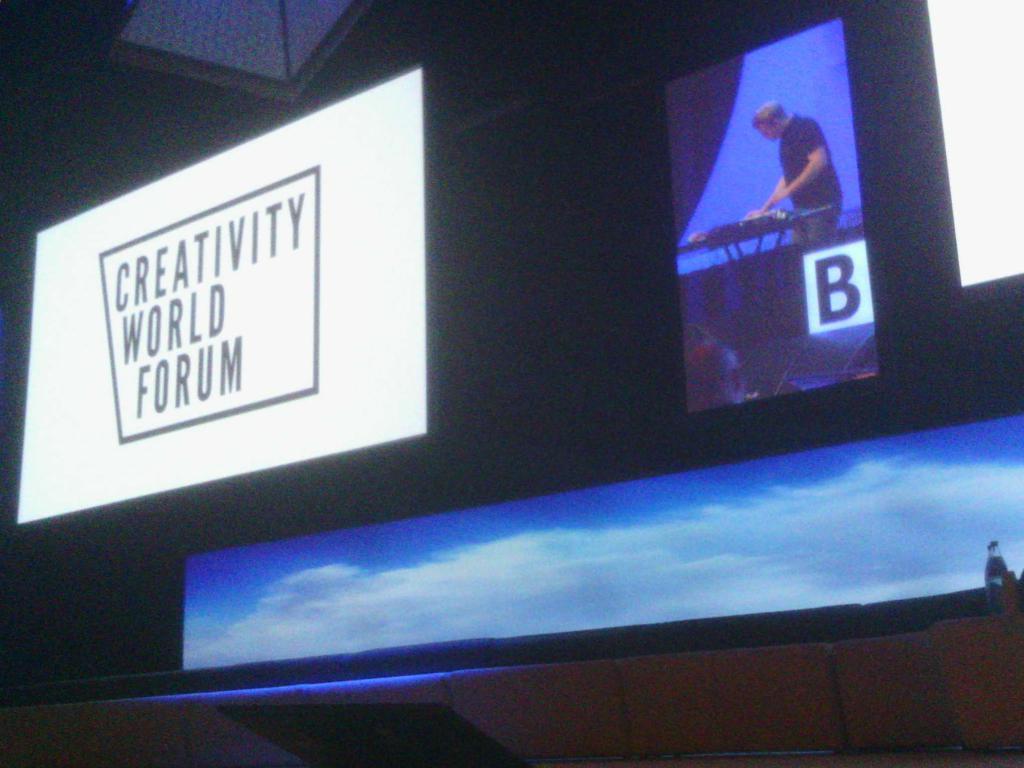Where is this convention being held at?
Make the answer very short. Creativity world forum. What is the name of the forum?
Your answer should be very brief. Creativity world forum. 